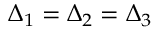<formula> <loc_0><loc_0><loc_500><loc_500>\Delta _ { 1 } = \Delta _ { 2 } = \Delta _ { 3 }</formula> 